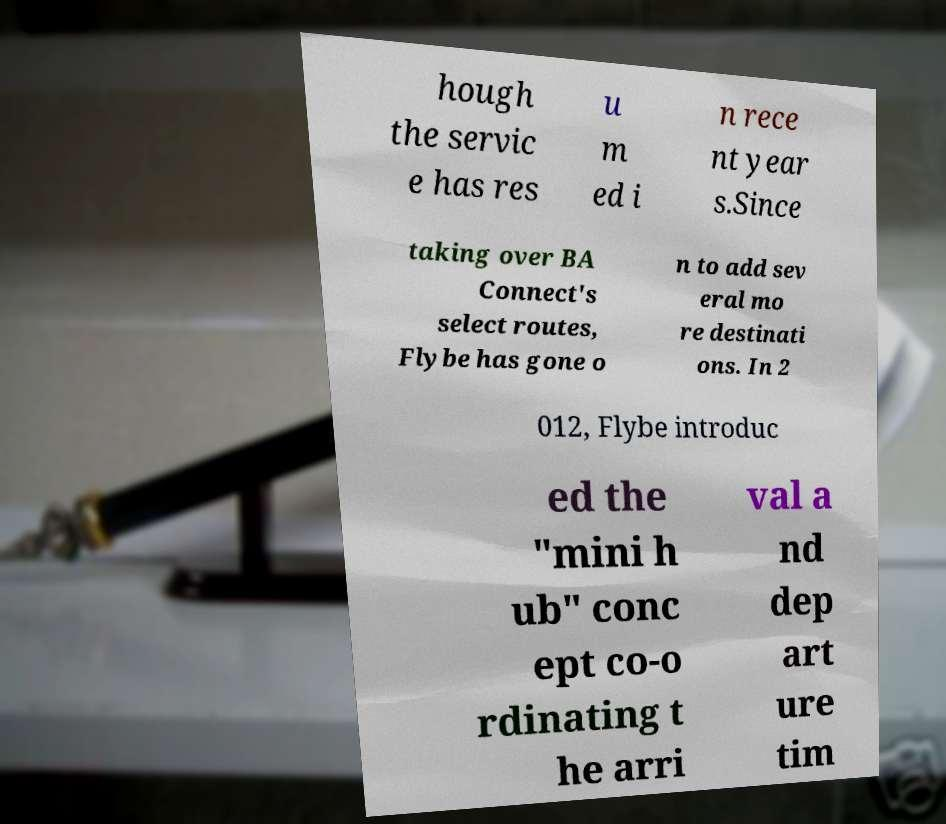For documentation purposes, I need the text within this image transcribed. Could you provide that? hough the servic e has res u m ed i n rece nt year s.Since taking over BA Connect's select routes, Flybe has gone o n to add sev eral mo re destinati ons. In 2 012, Flybe introduc ed the "mini h ub" conc ept co-o rdinating t he arri val a nd dep art ure tim 